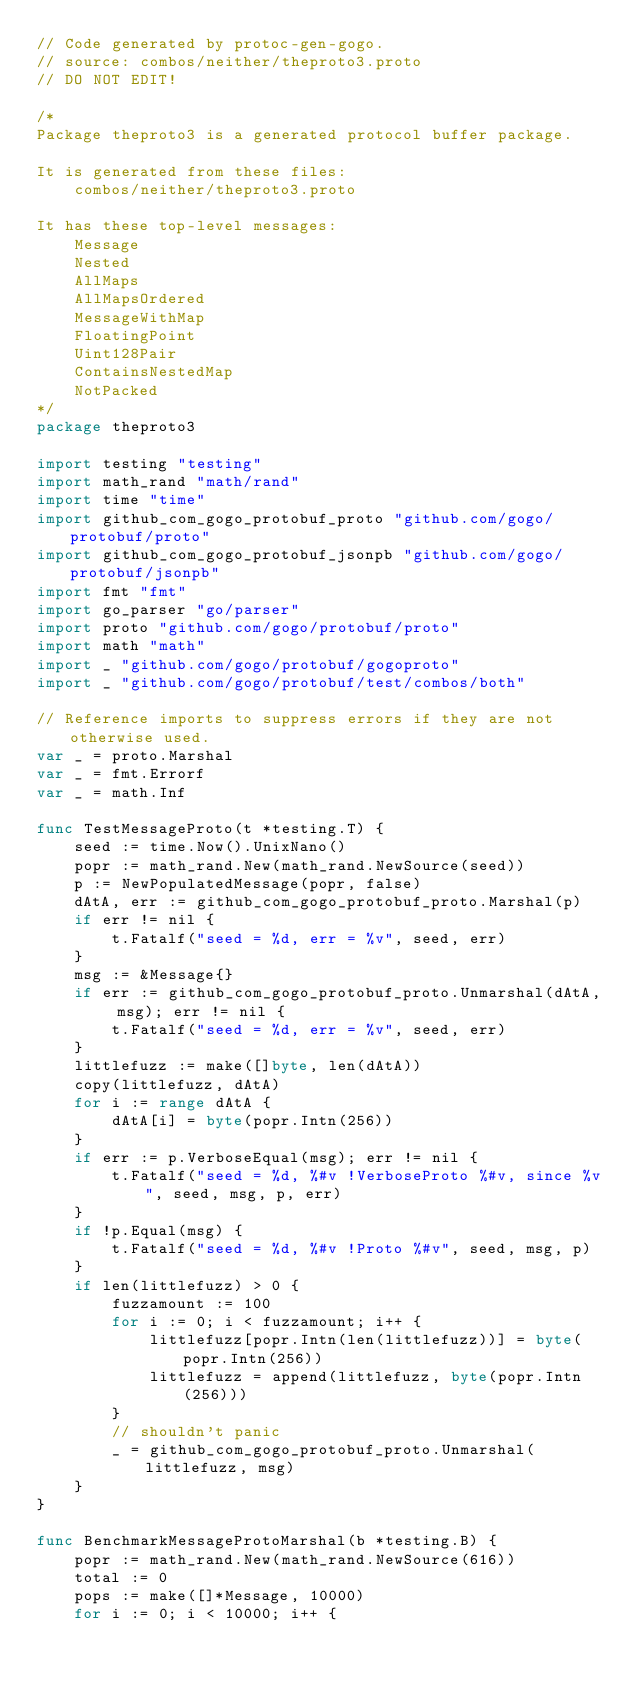Convert code to text. <code><loc_0><loc_0><loc_500><loc_500><_Go_>// Code generated by protoc-gen-gogo.
// source: combos/neither/theproto3.proto
// DO NOT EDIT!

/*
Package theproto3 is a generated protocol buffer package.

It is generated from these files:
	combos/neither/theproto3.proto

It has these top-level messages:
	Message
	Nested
	AllMaps
	AllMapsOrdered
	MessageWithMap
	FloatingPoint
	Uint128Pair
	ContainsNestedMap
	NotPacked
*/
package theproto3

import testing "testing"
import math_rand "math/rand"
import time "time"
import github_com_gogo_protobuf_proto "github.com/gogo/protobuf/proto"
import github_com_gogo_protobuf_jsonpb "github.com/gogo/protobuf/jsonpb"
import fmt "fmt"
import go_parser "go/parser"
import proto "github.com/gogo/protobuf/proto"
import math "math"
import _ "github.com/gogo/protobuf/gogoproto"
import _ "github.com/gogo/protobuf/test/combos/both"

// Reference imports to suppress errors if they are not otherwise used.
var _ = proto.Marshal
var _ = fmt.Errorf
var _ = math.Inf

func TestMessageProto(t *testing.T) {
	seed := time.Now().UnixNano()
	popr := math_rand.New(math_rand.NewSource(seed))
	p := NewPopulatedMessage(popr, false)
	dAtA, err := github_com_gogo_protobuf_proto.Marshal(p)
	if err != nil {
		t.Fatalf("seed = %d, err = %v", seed, err)
	}
	msg := &Message{}
	if err := github_com_gogo_protobuf_proto.Unmarshal(dAtA, msg); err != nil {
		t.Fatalf("seed = %d, err = %v", seed, err)
	}
	littlefuzz := make([]byte, len(dAtA))
	copy(littlefuzz, dAtA)
	for i := range dAtA {
		dAtA[i] = byte(popr.Intn(256))
	}
	if err := p.VerboseEqual(msg); err != nil {
		t.Fatalf("seed = %d, %#v !VerboseProto %#v, since %v", seed, msg, p, err)
	}
	if !p.Equal(msg) {
		t.Fatalf("seed = %d, %#v !Proto %#v", seed, msg, p)
	}
	if len(littlefuzz) > 0 {
		fuzzamount := 100
		for i := 0; i < fuzzamount; i++ {
			littlefuzz[popr.Intn(len(littlefuzz))] = byte(popr.Intn(256))
			littlefuzz = append(littlefuzz, byte(popr.Intn(256)))
		}
		// shouldn't panic
		_ = github_com_gogo_protobuf_proto.Unmarshal(littlefuzz, msg)
	}
}

func BenchmarkMessageProtoMarshal(b *testing.B) {
	popr := math_rand.New(math_rand.NewSource(616))
	total := 0
	pops := make([]*Message, 10000)
	for i := 0; i < 10000; i++ {</code> 